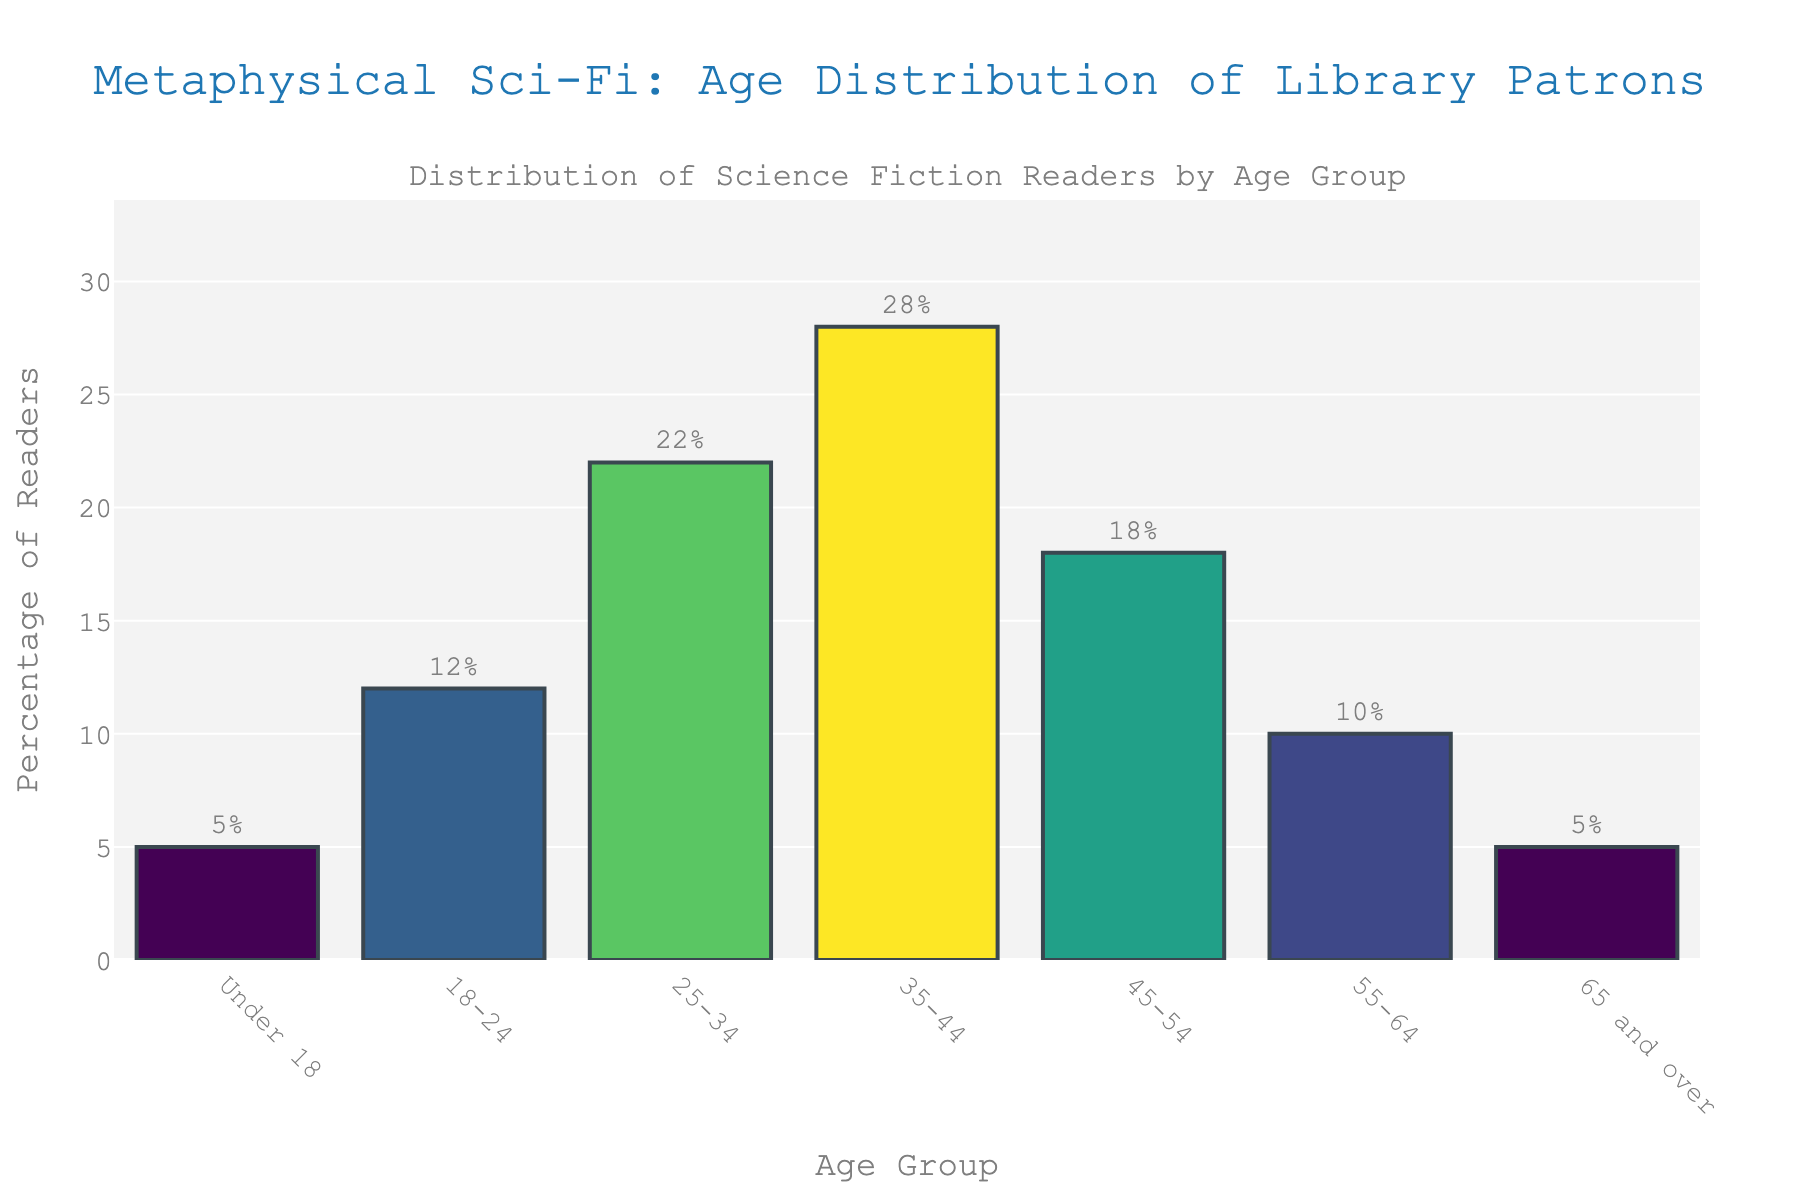What age group shows the highest percentage of readers interested in metaphysical sci-fi? The bar for the 35-44 age group is the tallest in the chart, which indicates it has the highest percentage of readers.
Answer: 35-44 Which two age groups have the lowest percentage of readers interested in metaphysical sci-fi, and what are their percentages? The two shortest bars are for the Under 18 and 65 and over age groups, both with a percentage of 5%.
Answer: Under 18 and 65 and over; 5% By how much does the percentage of readers in the 35-44 age group surpass the 18-24 age group? The percentage of readers in the 35-44 age group is 28%, and in the 18-24 age group it is 12%. The difference is 28% - 12% = 16%.
Answer: 16% What is the combined percentage of readers aged 45-54 and 55-64? The percentage for the 45-54 age group is 18% and for the 55-64 age group is 10%. Their combined percentage is 18% + 10% = 28%.
Answer: 28% Which age group has a percentage closest to the average percentage of all age groups? The average percentage is (5 + 12 + 22 + 28 + 18 + 10 + 5) / 7 = 100 / 7 ≈ 14.3%. The age group closest to this average is the 18-24 age group, with a percentage of 12%.
Answer: 18-24 Are there any age groups with an equal percentage of readership interest? If so, which ones? The bars for Under 18 and 65 and over are the same height, each with a percentage of 5%.
Answer: Under 18 and 65 and over Which age groups have a higher percentage than the overall average? The overall average is approximately 14.3%. The age groups with a higher percentage than this average are 25-34, 35-44, and 45-54.
Answer: 25-34, 35-44, and 45-54 What is the difference between the highest and lowest percentages? The highest percentage is 28% (35-44 age group), and the lowest percentage is 5% (Under 18 and 65 and over age groups). The difference is 28% - 5% = 23%.
Answer: 23% If the percentages were ranked, which age group would be in the middle? Sorting the percentages: 5%, 5%, 10%, 12%, 18%, 22%, 28%. The middle value is 12%, which belongs to the 18-24 age group.
Answer: 18-24 